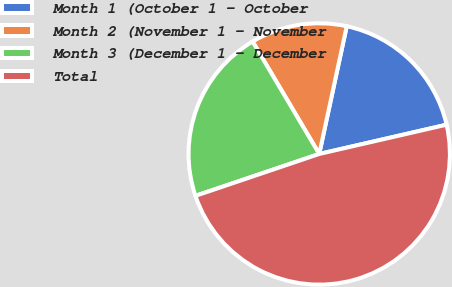Convert chart to OTSL. <chart><loc_0><loc_0><loc_500><loc_500><pie_chart><fcel>Month 1 (October 1 - October<fcel>Month 2 (November 1 - November<fcel>Month 3 (December 1 - December<fcel>Total<nl><fcel>18.03%<fcel>11.89%<fcel>21.68%<fcel>48.4%<nl></chart> 